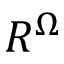Convert formula to latex. <formula><loc_0><loc_0><loc_500><loc_500>R ^ { \Omega }</formula> 